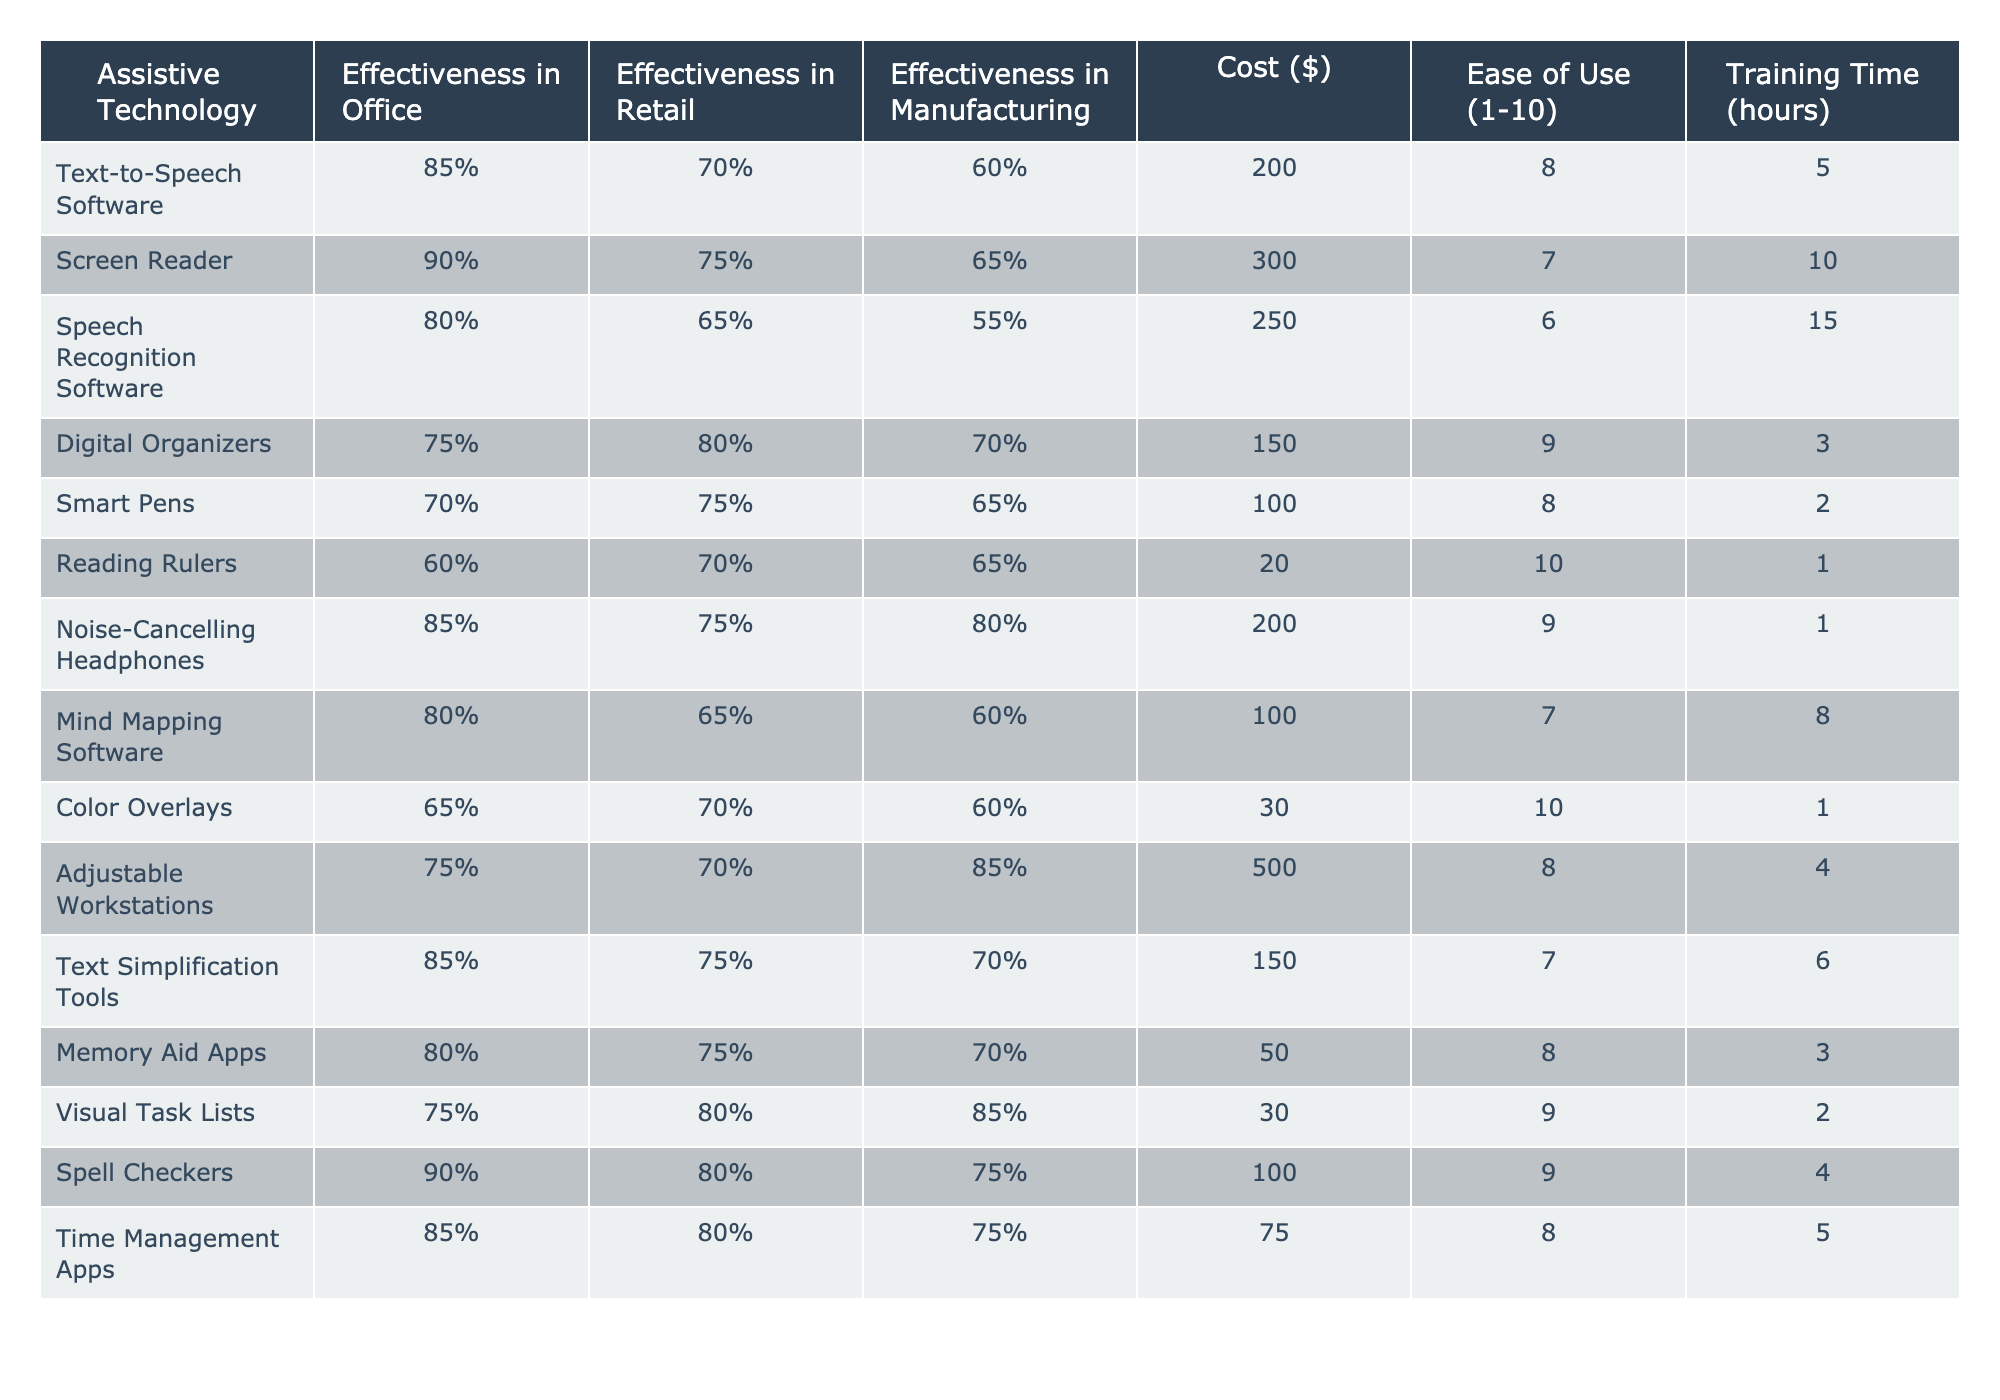What is the effectiveness of Text-to-Speech Software in the Office environment? According to the table, the effectiveness of Text-to-Speech Software in the Office is listed as 85%.
Answer: 85% Which assistive technology has the highest effectiveness in Retail? Looking at the effectiveness in Retail, Spell Checkers have the highest effectiveness at 80%.
Answer: Spell Checkers What is the average effectiveness of Digital Organizers across all work environments? Digital Organizers have effectiveness ratings of 75%, 80%, and 70% in Office, Retail, and Manufacturing, respectively. The average is (75 + 80 + 70) / 3 = 75%.
Answer: 75% Is the cost of Noise-Cancelling Headphones higher than that of Smart Pens? The cost of Noise-Cancelling Headphones is $200, while the cost of Smart Pens is $100. Since $200 is greater than $100, the statement is true.
Answer: Yes What is the effectiveness difference of Screen Reader between Office and Manufacturing? The effectiveness of Screen Reader in Office is 90%, while in Manufacturing it is 65%. The difference is 90% - 65% = 25%.
Answer: 25% How many assistive technologies have an effectiveness of 80% or higher in Office? Listing the effectiveness in the Office, Text-to-Speech Software, Screen Reader, Spell Checkers, Time Management Apps, and Text Simplification Tools all meet this criterion. That's a total of 5 technologies.
Answer: 5 What is the total training time required for using Speech Recognition Software and Adjustable Workstations? The training time for Speech Recognition Software is 15 hours and for Adjustable Workstations is 4 hours. Adding both gives 15 + 4 = 19 hours.
Answer: 19 hours Is the effectiveness of Color Overlays in Manufacturing greater than 60%? The effectiveness of Color Overlays in Manufacturing is 60%, which is not greater than 60%. Hence, the statement is false.
Answer: No Which assistive technology has the lowest effectiveness in Office? From the table, Reading Rulers have the lowest effectiveness in Office at 60%.
Answer: Reading Rulers If we consider only the top three most effective technologies in Office, what is their average effectiveness? The top three are Screen Reader (90%), Spell Checkers (90%), and Text-to-Speech Software (85%). The average is (90 + 90 + 85) / 3 = 88.33%, rounded to 88%.
Answer: 88% 